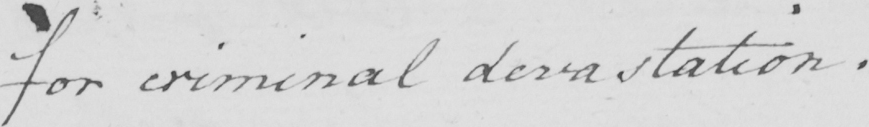Please transcribe the handwritten text in this image. for criminal devastation . 